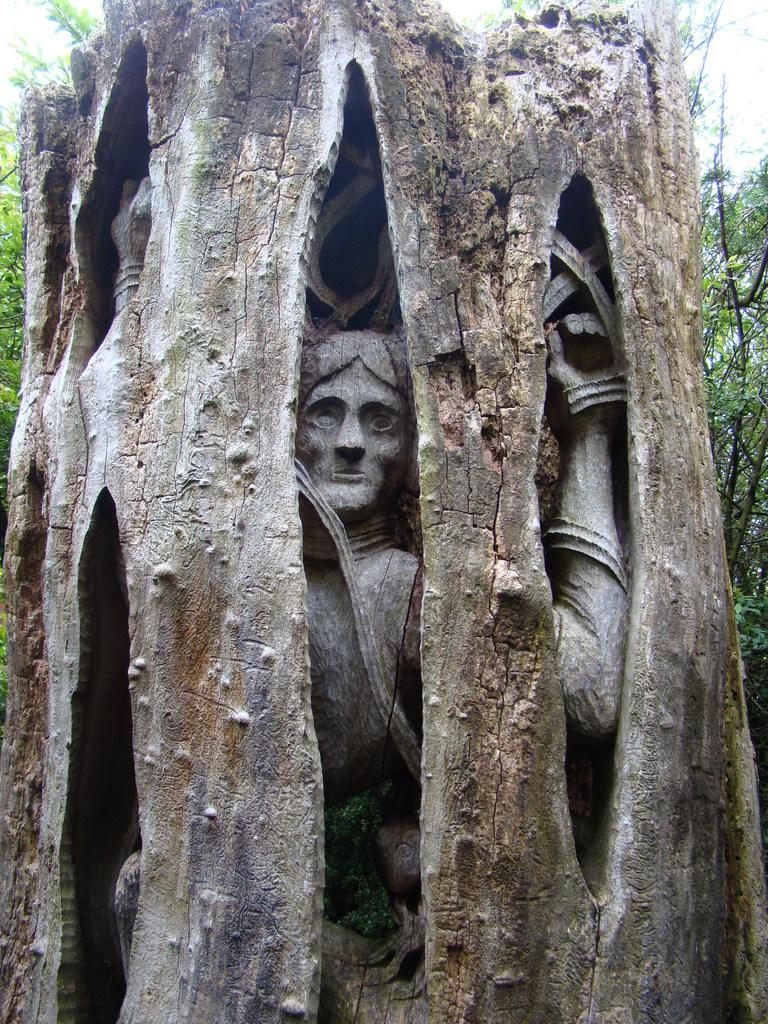What is located in the tree in the image? There is a statue in the tree. What else can be seen in the background of the image? There are additional trees in the background of the image. What type of pickle is hanging from the branches of the tree in the image? There is no pickle present in the image; it features a statue in the tree. What type of brass instrument can be seen being played by the statue in the image? There is no brass instrument or any musical instrument visible in the image; the statue is simply located in the tree. 